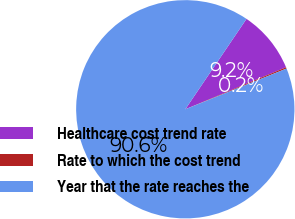Convert chart to OTSL. <chart><loc_0><loc_0><loc_500><loc_500><pie_chart><fcel>Healthcare cost trend rate<fcel>Rate to which the cost trend<fcel>Year that the rate reaches the<nl><fcel>9.24%<fcel>0.2%<fcel>90.56%<nl></chart> 